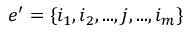Convert formula to latex. <formula><loc_0><loc_0><loc_500><loc_500>e ^ { \prime } = \{ i _ { 1 } , i _ { 2 } , \dots , j , \dots , i _ { m } \}</formula> 